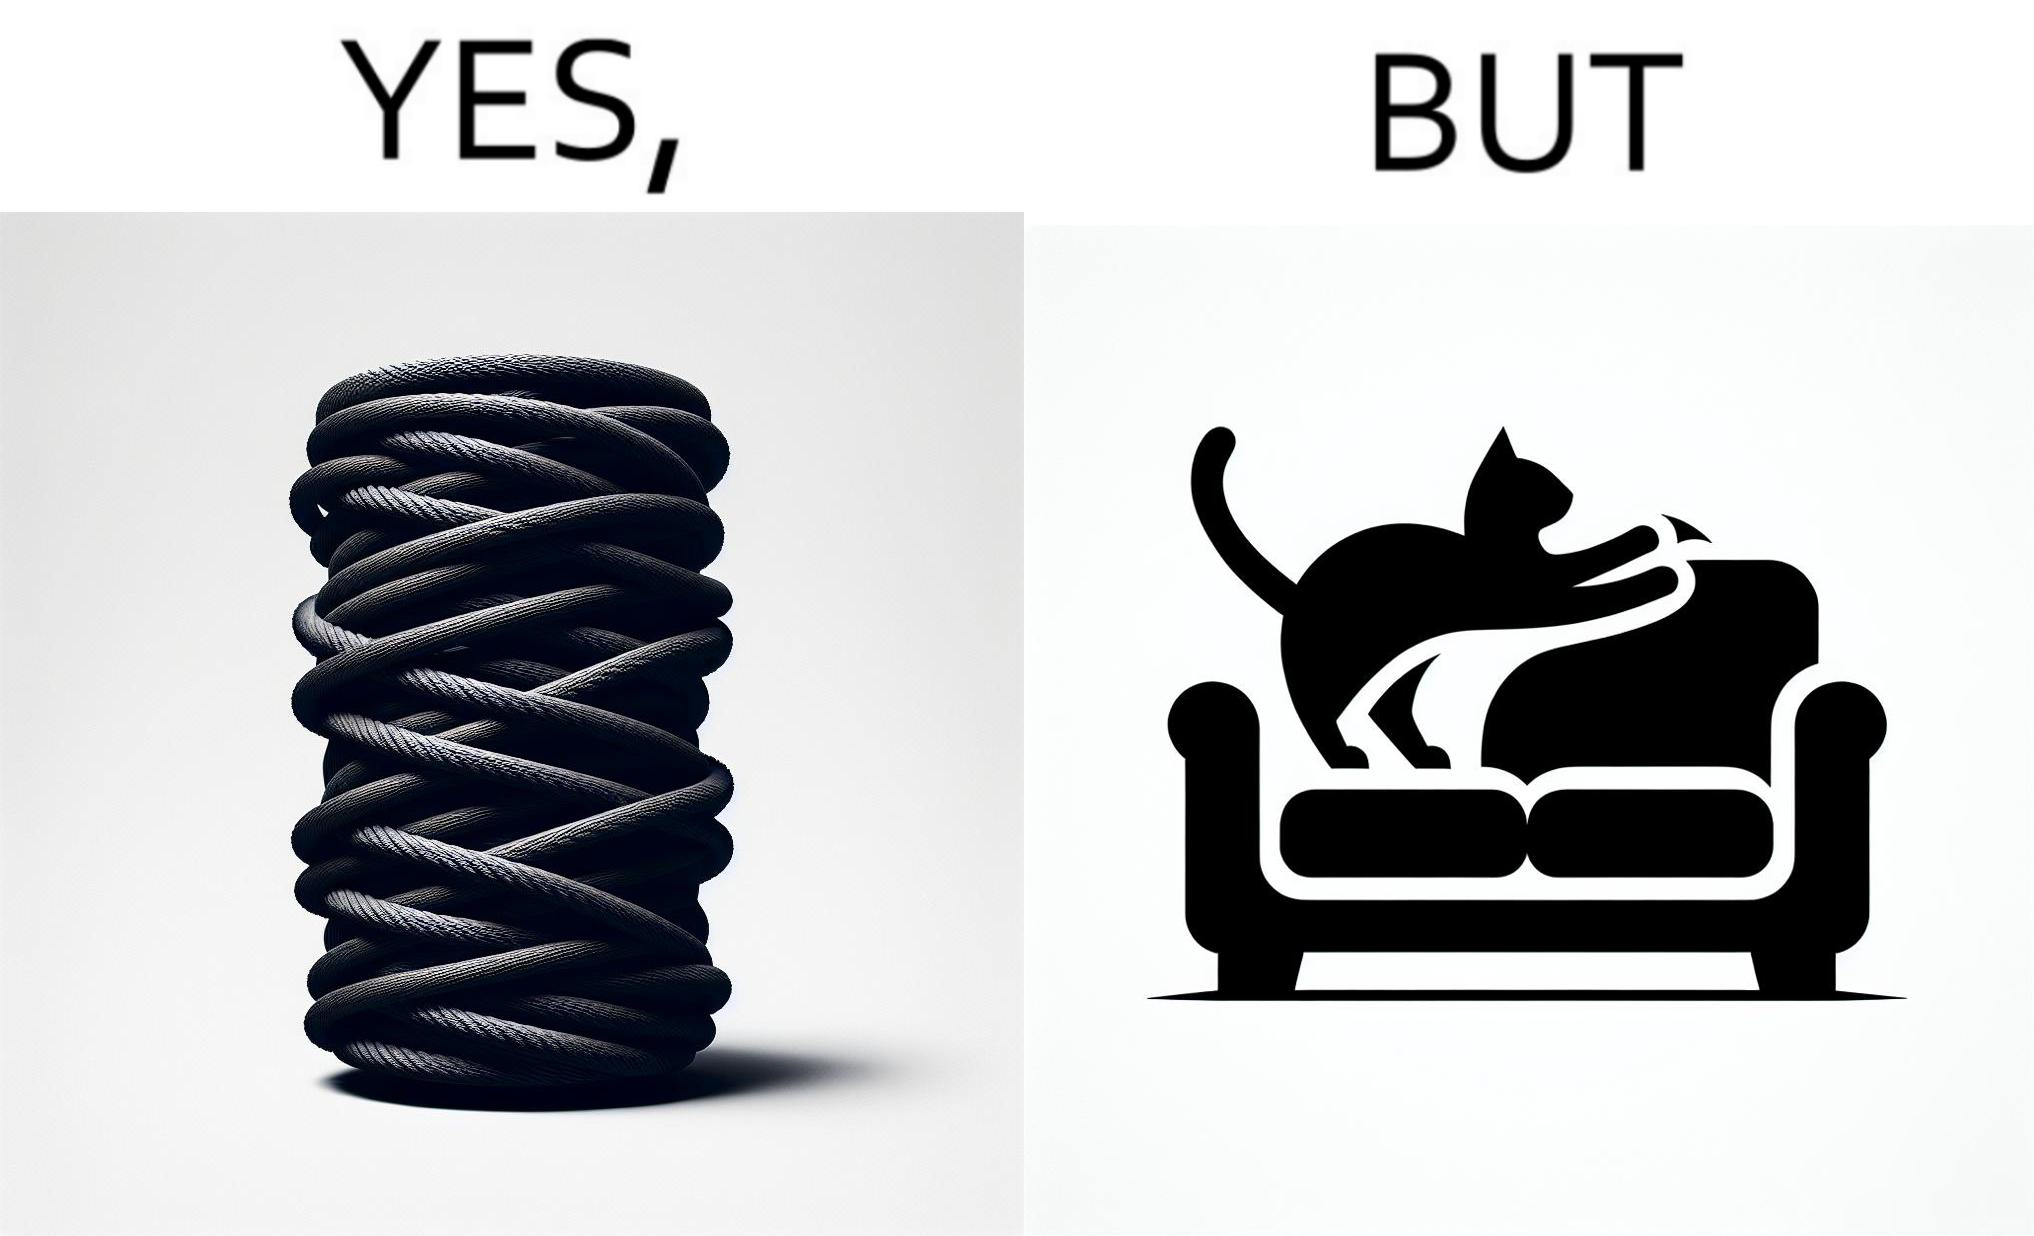Does this image contain satire or humor? Yes, this image is satirical. 